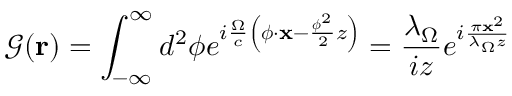Convert formula to latex. <formula><loc_0><loc_0><loc_500><loc_500>\mathcal { G } ( r ) = \int _ { - \infty } ^ { \infty } d ^ { 2 } \phi e ^ { i \frac { \Omega } { c } \left ( \phi \cdot \mathbf x - \frac { \phi ^ { 2 } } { 2 } z \right ) } = \frac { \lambda _ { \Omega } } { i z } e ^ { i \frac { \pi x ^ { 2 } } { \lambda _ { \Omega } z } }</formula> 